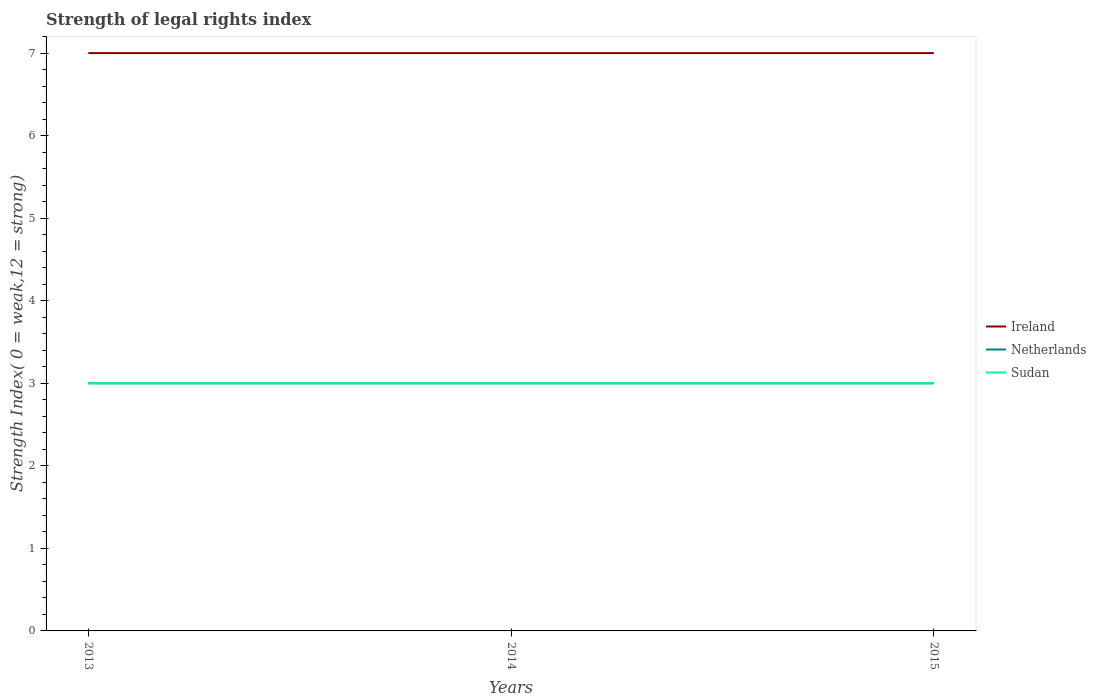Does the line corresponding to Ireland intersect with the line corresponding to Sudan?
Your answer should be compact. No. Across all years, what is the maximum strength index in Sudan?
Your response must be concise. 3. In which year was the strength index in Ireland maximum?
Your answer should be very brief. 2013. What is the total strength index in Sudan in the graph?
Make the answer very short. 0. What is the difference between the highest and the second highest strength index in Ireland?
Provide a succinct answer. 0. What is the difference between the highest and the lowest strength index in Ireland?
Give a very brief answer. 0. Is the strength index in Ireland strictly greater than the strength index in Sudan over the years?
Give a very brief answer. No. How many years are there in the graph?
Make the answer very short. 3. Where does the legend appear in the graph?
Ensure brevity in your answer.  Center right. How many legend labels are there?
Offer a terse response. 3. What is the title of the graph?
Offer a terse response. Strength of legal rights index. Does "Russian Federation" appear as one of the legend labels in the graph?
Make the answer very short. No. What is the label or title of the Y-axis?
Offer a terse response. Strength Index( 0 = weak,12 = strong). What is the Strength Index( 0 = weak,12 = strong) of Ireland in 2014?
Keep it short and to the point. 7. What is the Strength Index( 0 = weak,12 = strong) in Netherlands in 2014?
Offer a terse response. 3. What is the Strength Index( 0 = weak,12 = strong) of Ireland in 2015?
Make the answer very short. 7. What is the Strength Index( 0 = weak,12 = strong) in Netherlands in 2015?
Ensure brevity in your answer.  3. What is the Strength Index( 0 = weak,12 = strong) in Sudan in 2015?
Make the answer very short. 3. Across all years, what is the maximum Strength Index( 0 = weak,12 = strong) of Sudan?
Your response must be concise. 3. Across all years, what is the minimum Strength Index( 0 = weak,12 = strong) in Netherlands?
Keep it short and to the point. 3. Across all years, what is the minimum Strength Index( 0 = weak,12 = strong) in Sudan?
Your answer should be very brief. 3. What is the total Strength Index( 0 = weak,12 = strong) in Ireland in the graph?
Provide a short and direct response. 21. What is the total Strength Index( 0 = weak,12 = strong) in Sudan in the graph?
Ensure brevity in your answer.  9. What is the difference between the Strength Index( 0 = weak,12 = strong) of Netherlands in 2013 and that in 2014?
Give a very brief answer. 0. What is the difference between the Strength Index( 0 = weak,12 = strong) in Ireland in 2013 and the Strength Index( 0 = weak,12 = strong) in Sudan in 2014?
Offer a terse response. 4. What is the difference between the Strength Index( 0 = weak,12 = strong) in Netherlands in 2013 and the Strength Index( 0 = weak,12 = strong) in Sudan in 2014?
Provide a succinct answer. 0. What is the difference between the Strength Index( 0 = weak,12 = strong) of Ireland in 2013 and the Strength Index( 0 = weak,12 = strong) of Netherlands in 2015?
Make the answer very short. 4. What is the difference between the Strength Index( 0 = weak,12 = strong) in Netherlands in 2013 and the Strength Index( 0 = weak,12 = strong) in Sudan in 2015?
Keep it short and to the point. 0. What is the difference between the Strength Index( 0 = weak,12 = strong) of Netherlands in 2014 and the Strength Index( 0 = weak,12 = strong) of Sudan in 2015?
Provide a short and direct response. 0. In the year 2013, what is the difference between the Strength Index( 0 = weak,12 = strong) of Netherlands and Strength Index( 0 = weak,12 = strong) of Sudan?
Give a very brief answer. 0. In the year 2014, what is the difference between the Strength Index( 0 = weak,12 = strong) in Ireland and Strength Index( 0 = weak,12 = strong) in Netherlands?
Your answer should be compact. 4. In the year 2015, what is the difference between the Strength Index( 0 = weak,12 = strong) in Ireland and Strength Index( 0 = weak,12 = strong) in Netherlands?
Make the answer very short. 4. In the year 2015, what is the difference between the Strength Index( 0 = weak,12 = strong) in Ireland and Strength Index( 0 = weak,12 = strong) in Sudan?
Give a very brief answer. 4. What is the ratio of the Strength Index( 0 = weak,12 = strong) of Netherlands in 2013 to that in 2014?
Give a very brief answer. 1. What is the ratio of the Strength Index( 0 = weak,12 = strong) in Ireland in 2013 to that in 2015?
Offer a terse response. 1. What is the ratio of the Strength Index( 0 = weak,12 = strong) in Netherlands in 2013 to that in 2015?
Your response must be concise. 1. What is the ratio of the Strength Index( 0 = weak,12 = strong) of Sudan in 2014 to that in 2015?
Keep it short and to the point. 1. What is the difference between the highest and the second highest Strength Index( 0 = weak,12 = strong) of Netherlands?
Your answer should be compact. 0. 